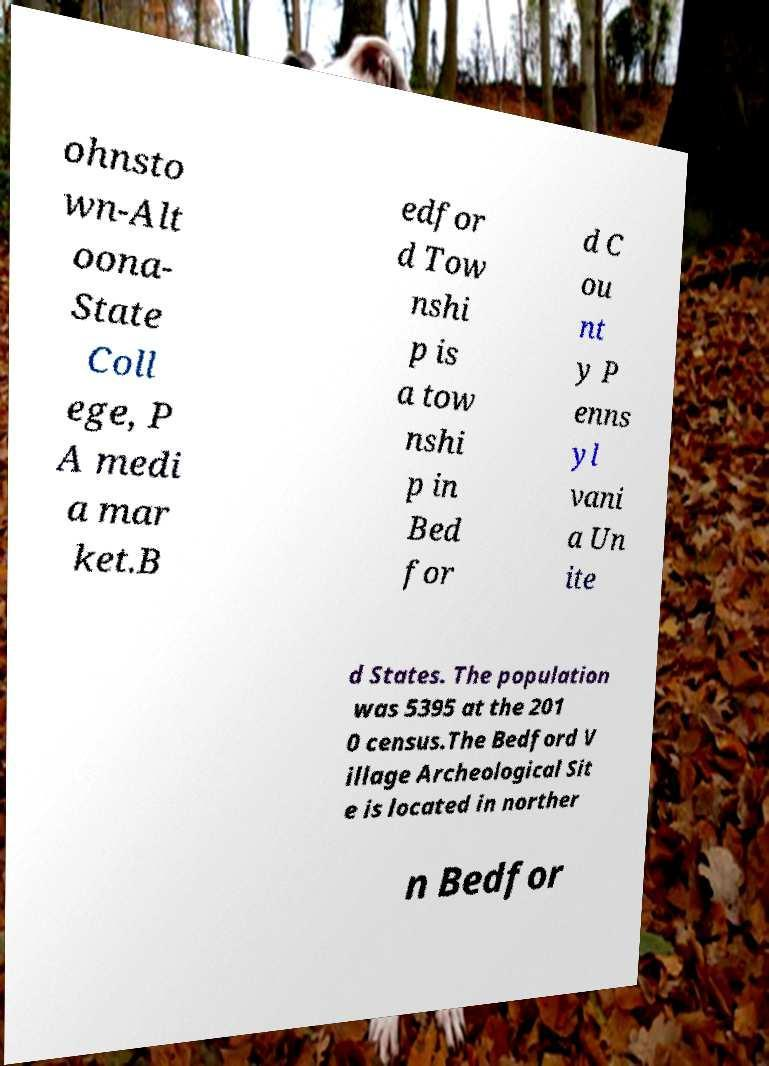Can you accurately transcribe the text from the provided image for me? ohnsto wn-Alt oona- State Coll ege, P A medi a mar ket.B edfor d Tow nshi p is a tow nshi p in Bed for d C ou nt y P enns yl vani a Un ite d States. The population was 5395 at the 201 0 census.The Bedford V illage Archeological Sit e is located in norther n Bedfor 